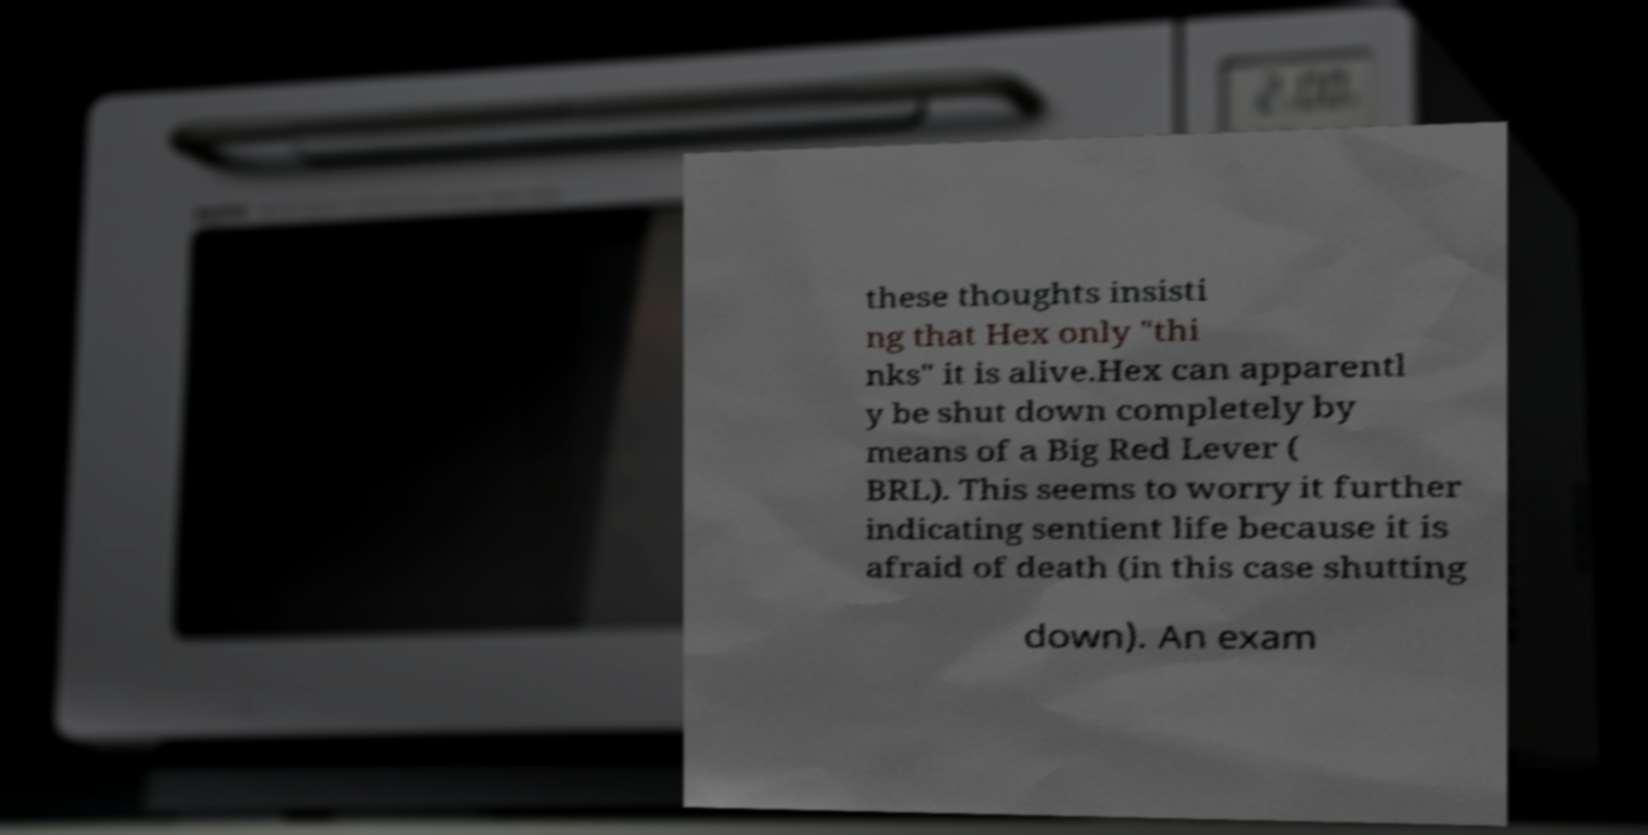Could you assist in decoding the text presented in this image and type it out clearly? these thoughts insisti ng that Hex only "thi nks" it is alive.Hex can apparentl y be shut down completely by means of a Big Red Lever ( BRL). This seems to worry it further indicating sentient life because it is afraid of death (in this case shutting down). An exam 